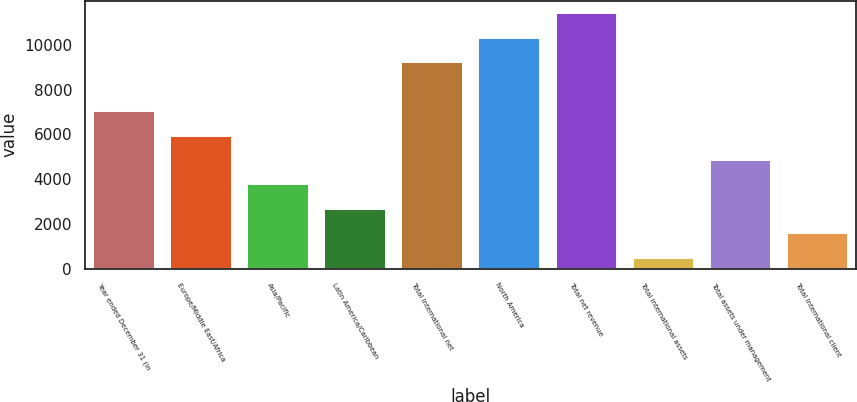<chart> <loc_0><loc_0><loc_500><loc_500><bar_chart><fcel>Year ended December 31 (in<fcel>Europe/Middle East/Africa<fcel>Asia/Pacific<fcel>Latin America/Caribbean<fcel>Total international net<fcel>North America<fcel>Total net revenue<fcel>Total international assets<fcel>Total assets under management<fcel>Total international client<nl><fcel>7036.6<fcel>5944.5<fcel>3760.3<fcel>2668.2<fcel>9220.8<fcel>10312.9<fcel>11405<fcel>484<fcel>4852.4<fcel>1576.1<nl></chart> 